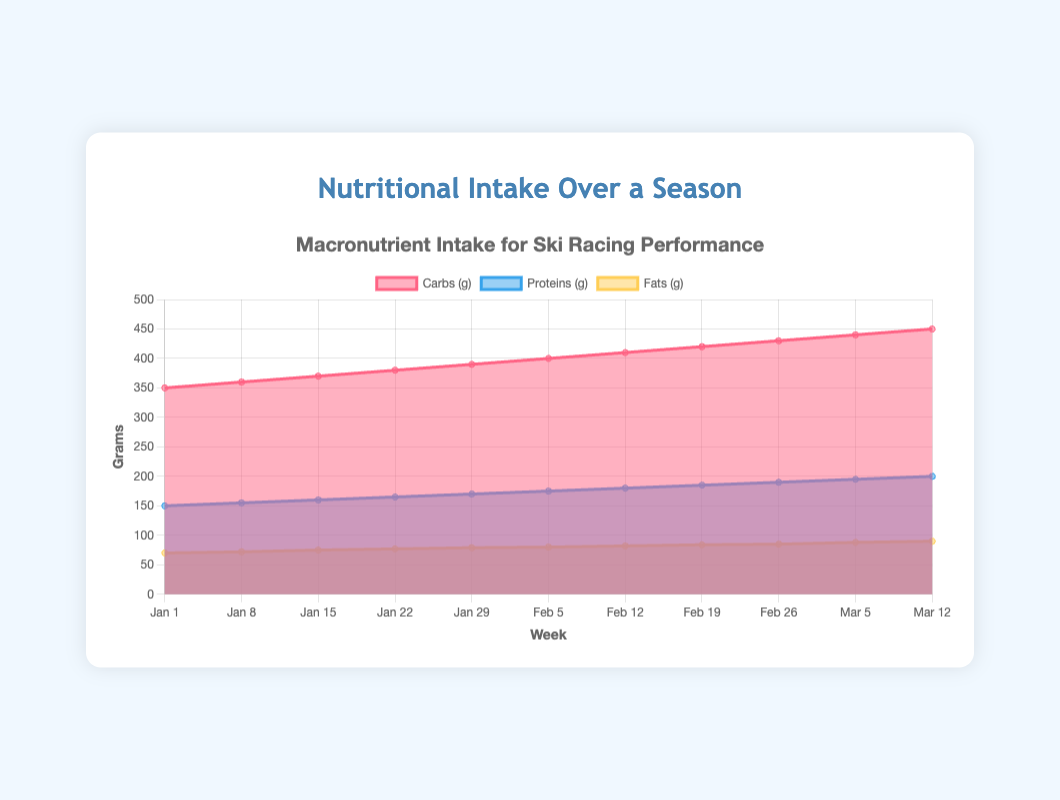What's the total intake of macronutrients (carbs, proteins, and fats) for the week of January 1st? For the week of January 1st, the carbs intake is 350 grams, proteins intake is 150 grams, and fats intake is 70 grams. Adding these together: 350 + 150 + 70 = 570 grams.
Answer: 570 grams Which week saw the highest intake of proteins? By examining the graph, the week of March 12th has the highest intake of proteins with 200 grams, as this is the last value in the increasing trend of protein intake.
Answer: March 12th How does the intake of fats compare between January 1st and March 12th? On January 1st, the fats intake is 70 grams, and on March 12th, it's 90 grams. Comparing these values, March 12th has more fats intake by 20 grams (90 - 70).
Answer: March 12th has 20 grams more fats intake What's the trend in carb intake over the season? The carb intake consistently increases every week from January 1st to March 12th, starting at 350 grams and ending at 450 grams, showing a uniform upward trend.
Answer: Consistently increasing Calculate the average weekly intake of proteins over the 11 weeks. Sum of protein intakes over 11 weeks is: 150 + 155 + 160 + 165 + 170 + 175 + 180 + 185 + 190 + 195 + 200 = 1925 grams. Dividing by 11 weeks: 1925 / 11 ≈ 175 grams.
Answer: 175 grams Was there any week where the intake of fats decreased compared to the previous week? By reviewing the data, every week shows an increase or stays the same in fats intake; there's no week with a decrease.
Answer: No What was the total increase in carbs from January 1st to March 12th? The carbs intake on January 1st was 350 grams, and on March 12th, it was 450 grams. Total increase: 450 - 350 = 100 grams.
Answer: 100 grams Which macronutrient had the least increase in intake over the season? Comparing the increases: carbs from 350 to 450 (100 grams), proteins from 150 to 200 (50 grams), fats from 70 to 90 (20 grams). Fats had the least increase with only 20 grams.
Answer: Fats 